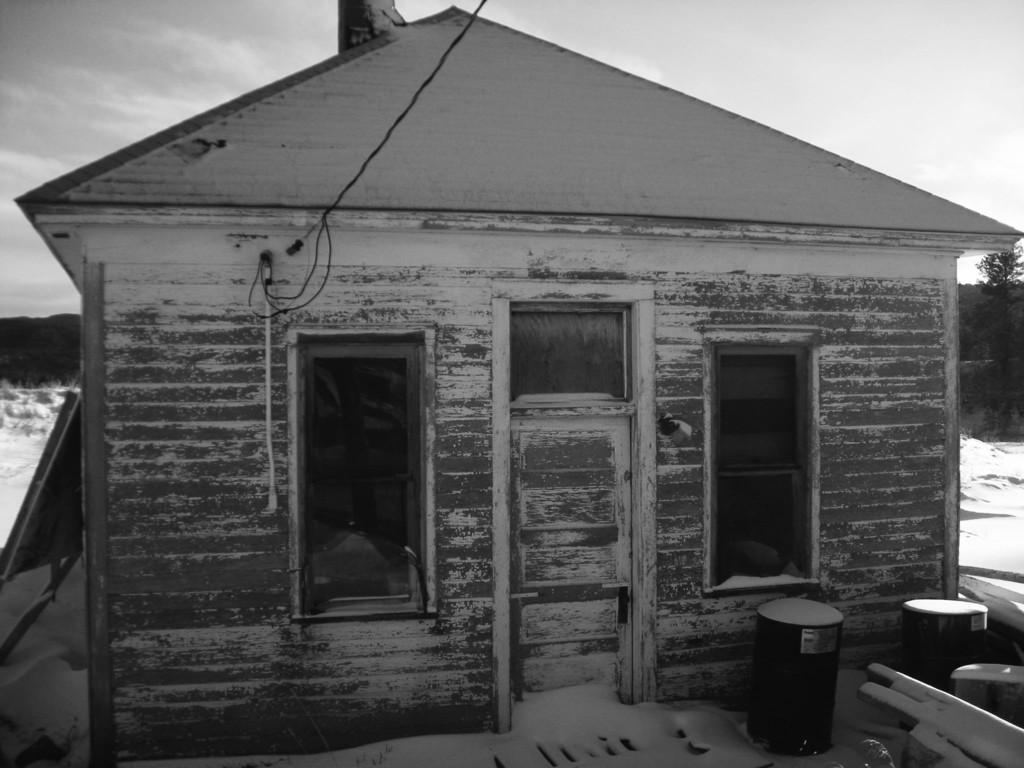How would you summarize this image in a sentence or two? In this picture I can see a house in front and I see few things on the right bottom of this picture. On the top of the house I can see 2 wires. In the background I can see the trees and the sky. I see that this is a black and white image. 